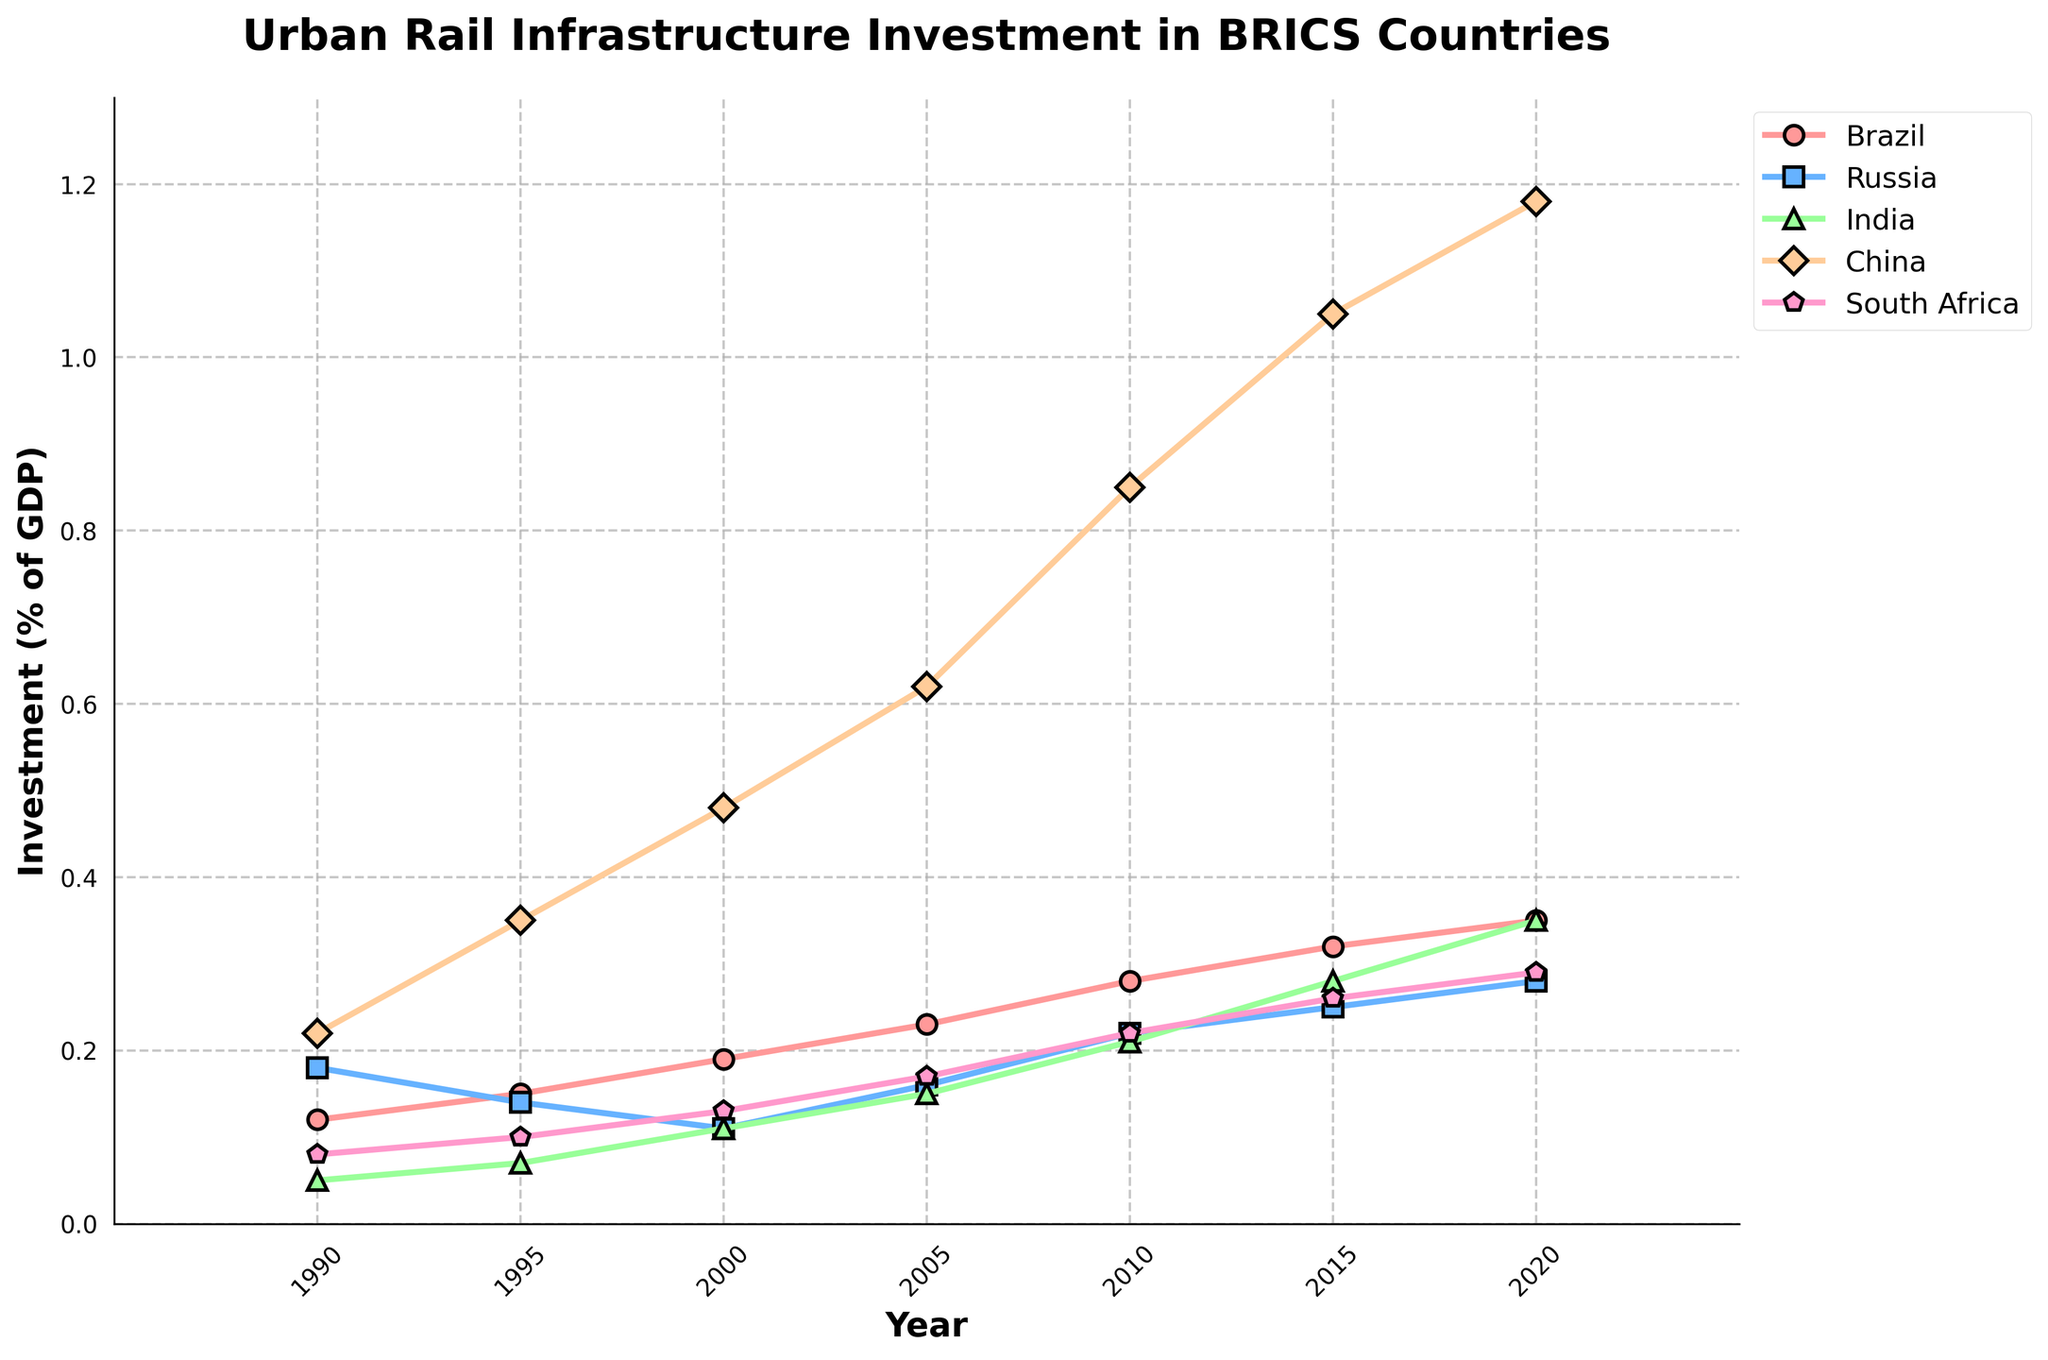What year did Brazil's investment in urban rail infrastructure surpass 0.3% of its GDP? Brazil's investment in urban rail surpassed 0.3% of GDP in 2015. This can be seen by looking at the y-axis value for Brazil in 2015.
Answer: 2015 In 2020, which country had the highest investment in urban rail infrastructure as a percentage of GDP? In 2020, China had the highest investment in urban rail infrastructure as a percentage of GDP. This can be determined by comparing the y-axis values for all countries in 2020, where China's value is 1.18%.
Answer: China Between 1990 and 2020, by how much did India's investment in urban rail infrastructure as a percentage of GDP increase? India's investment increased from 0.05% in 1990 to 0.35% in 2020. The increase is calculated as 0.35% - 0.05% = 0.30%.
Answer: 0.30% In which year did South Africa's investment in urban rail infrastructure reach approximately 0.25% of GDP, and did it ever exceed this value by 2020? South Africa's investment reached approximately 0.25% of GDP in 2015 and exceeded this value (0.29%) in 2020. This is observed by checking the y-axis values for South Africa in the given years.
Answer: 2015 and Yes Which country showed the most consistent increase in investment in urban rail infrastructure as a percentage of GDP from 1990 to 2020? China showed the most consistent increase in investment, as evident by the steadily increasing slope of China's line from 1990 to 2020.
Answer: China By how much did Russia's investment in urban rail as a percentage of GDP change from 1995 to 2005? Russia's investment changed from 0.14% in 1995 to 0.16% in 2005, an increase of 0.16% - 0.14% = 0.02%.
Answer: 0.02% In which year did all BRICS countries have their lowest investment in urban rail infrastructure within the provided time frame? The lowest investment for all BRICS countries was in 1990, judging by the initial points of each country's line, which are the lowest on the y-axis.
Answer: 1990 Which two countries had the closest investment values in 2010, and what were those values? In 2010, Russia and South Africa had the closest investment values, with Russia at 0.22% and South Africa at 0.22%, both having the exact same values.
Answer: Russia and South Africa, 0.22% How did the investment trend of India compare to Brazil over the entire period from 1990 to 2020? India's investment showed a steady increase from 0.05% to 0.35%, whereas Brazil started higher and also increased steadily from 0.12% to 0.35%. Both countries ended at 0.35% in 2020.
Answer: Similar increasing trends 